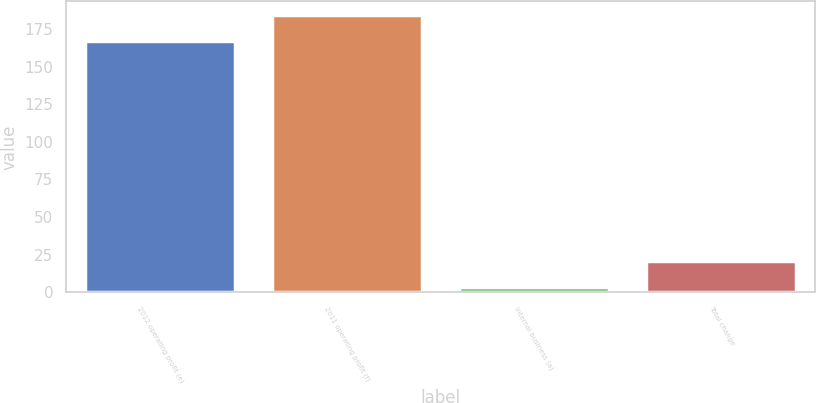<chart> <loc_0><loc_0><loc_500><loc_500><bar_chart><fcel>2012 operating profit (e)<fcel>2011 operating profit (f)<fcel>Internal business (a)<fcel>Total change<nl><fcel>167<fcel>184.23<fcel>3.7<fcel>20.93<nl></chart> 